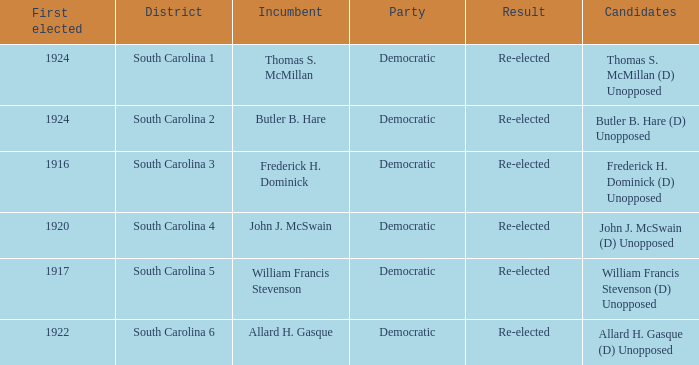What is the party for south carolina 3? Democratic. 